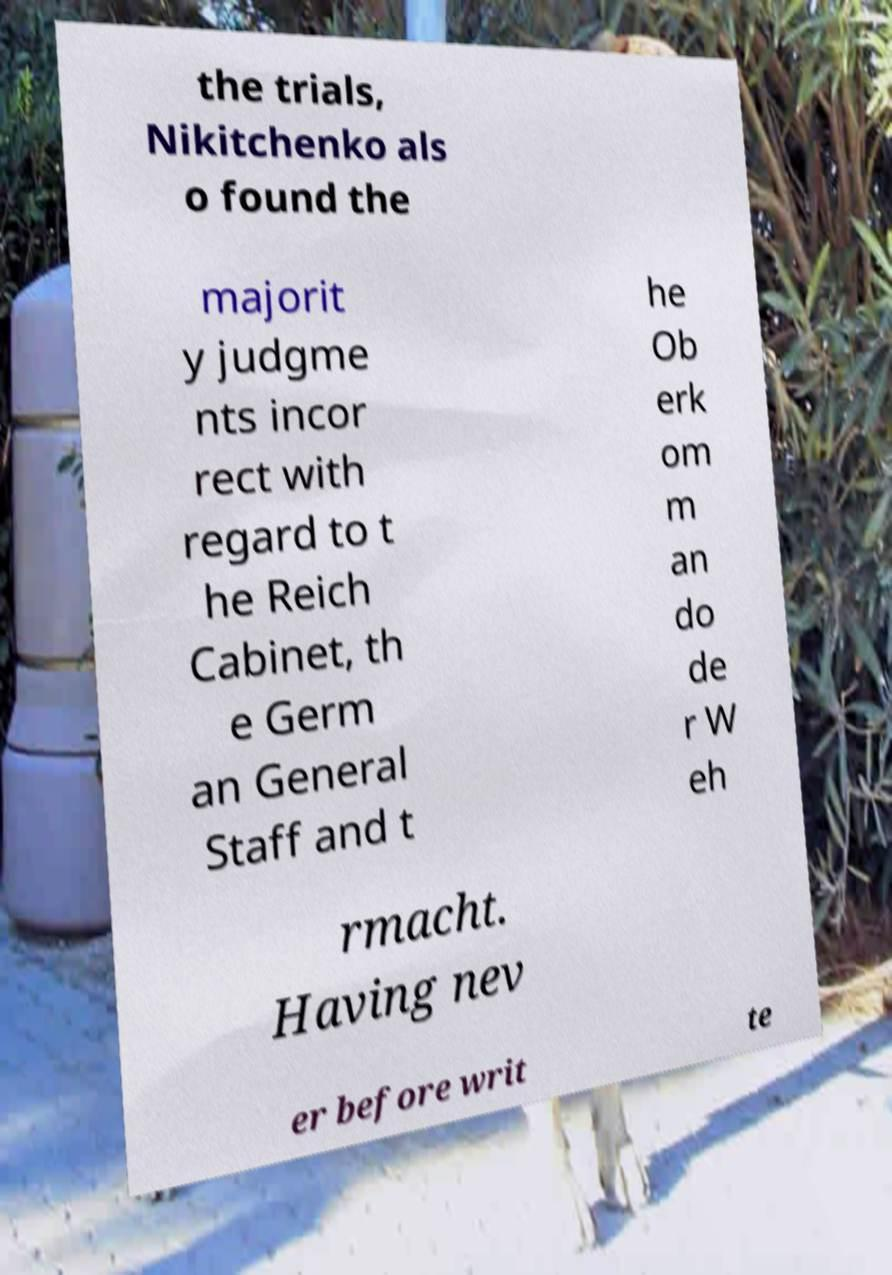Can you read and provide the text displayed in the image?This photo seems to have some interesting text. Can you extract and type it out for me? the trials, Nikitchenko als o found the majorit y judgme nts incor rect with regard to t he Reich Cabinet, th e Germ an General Staff and t he Ob erk om m an do de r W eh rmacht. Having nev er before writ te 